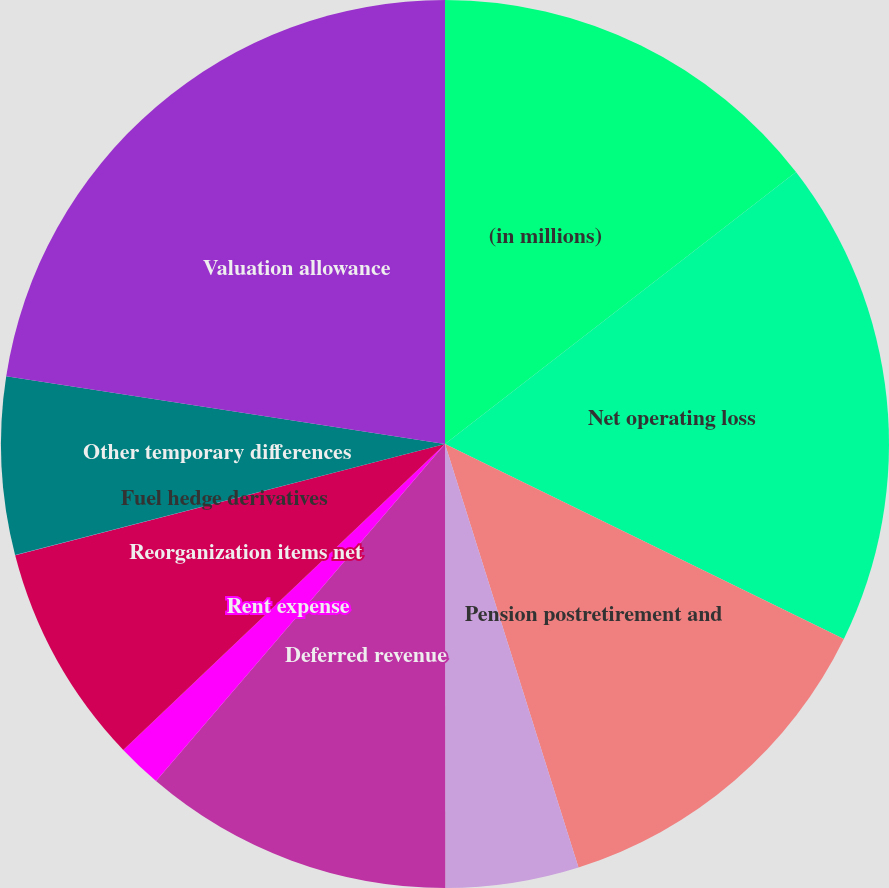Convert chart to OTSL. <chart><loc_0><loc_0><loc_500><loc_500><pie_chart><fcel>(in millions)<fcel>Net operating loss<fcel>Pension postretirement and<fcel>AMT credit carryforward<fcel>Deferred revenue<fcel>Rent expense<fcel>Reorganization items net<fcel>Fuel hedge derivatives<fcel>Other temporary differences<fcel>Valuation allowance<nl><fcel>14.51%<fcel>17.73%<fcel>12.9%<fcel>4.85%<fcel>11.29%<fcel>1.62%<fcel>8.07%<fcel>0.01%<fcel>6.46%<fcel>22.56%<nl></chart> 